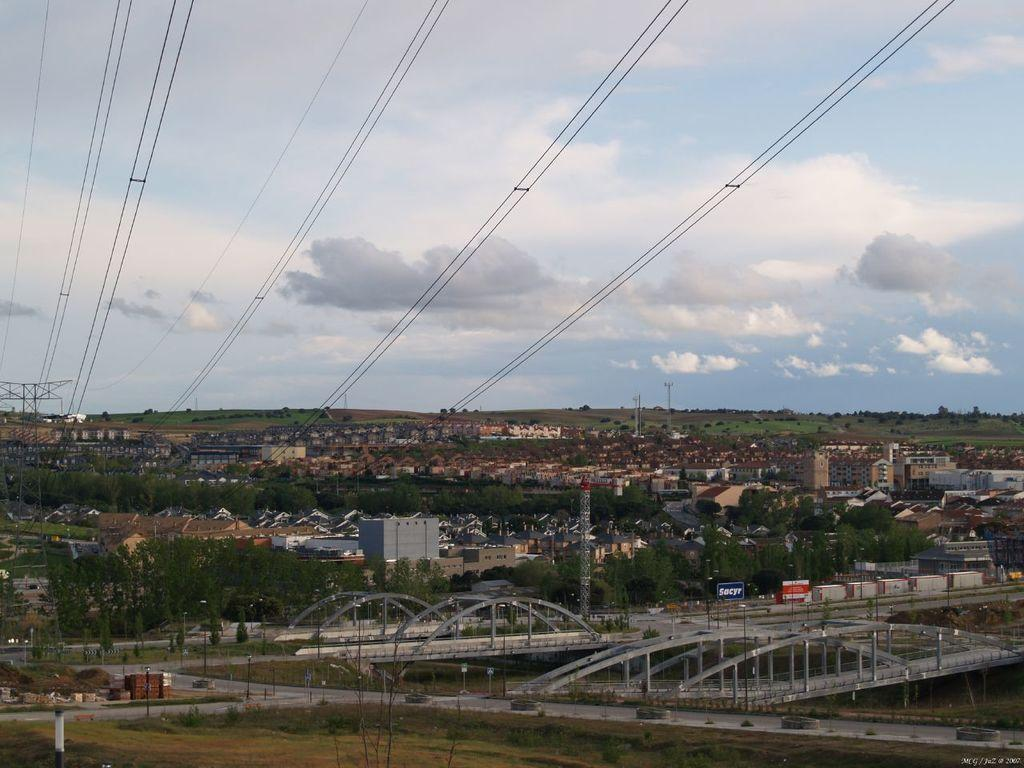What is the main subject of the image? The main subject of the image is a view of a town. What type of structures can be seen in the town? There are metal bridges, buildings, and small houses in the town. What other elements are visible in the image? There are cables and an electric tower visible in the image. What type of caption is written on the basketball in the image? There is no basketball present in the image, so there is no caption to be read. Can you describe the ocean visible in the image? There is no ocean visible in the image; it features a view of a town with various structures and elements. 